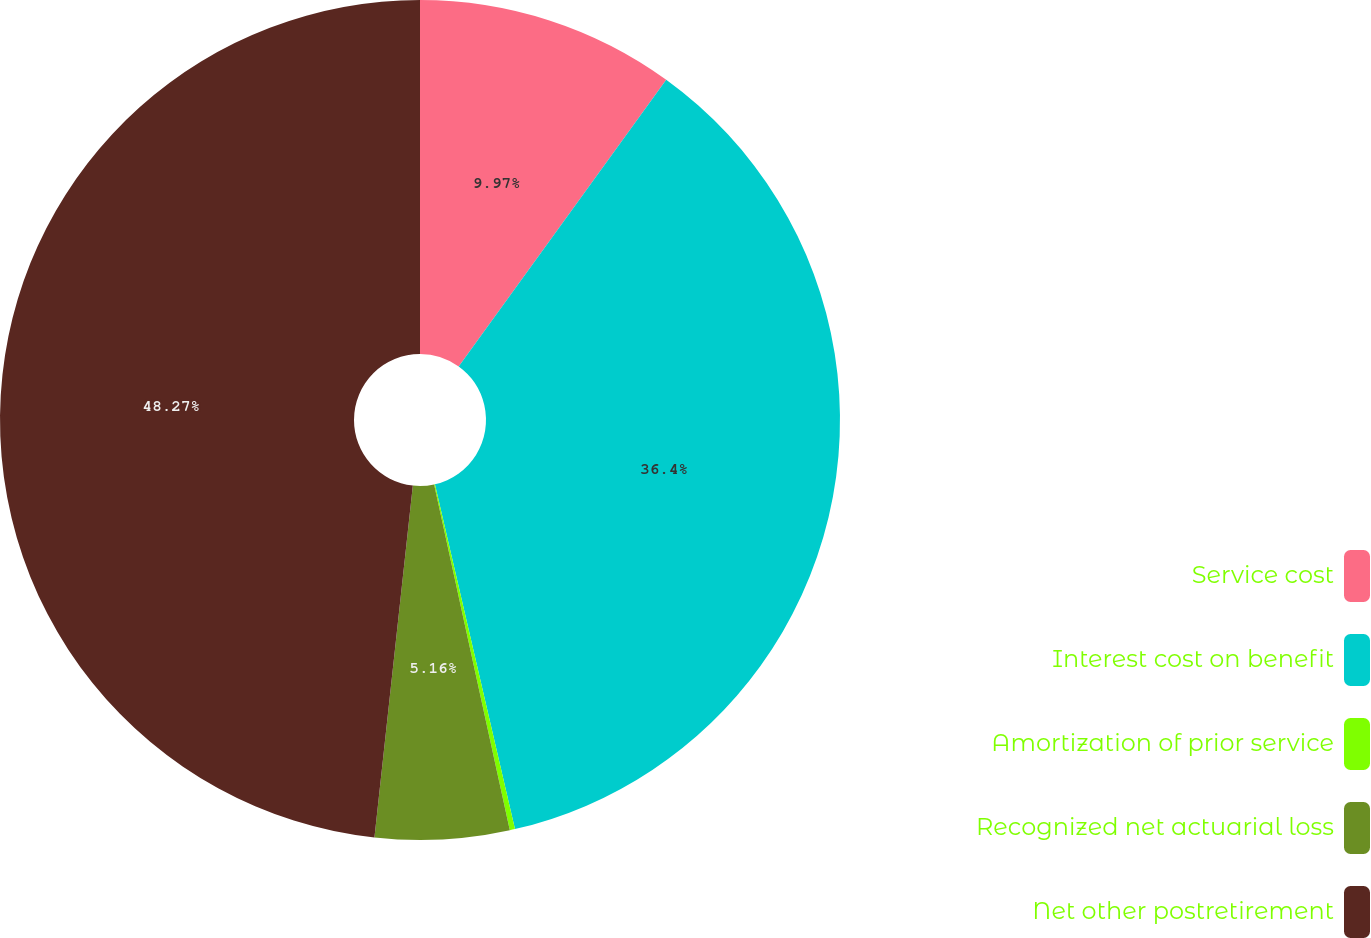<chart> <loc_0><loc_0><loc_500><loc_500><pie_chart><fcel>Service cost<fcel>Interest cost on benefit<fcel>Amortization of prior service<fcel>Recognized net actuarial loss<fcel>Net other postretirement<nl><fcel>9.97%<fcel>36.4%<fcel>0.2%<fcel>5.16%<fcel>48.27%<nl></chart> 